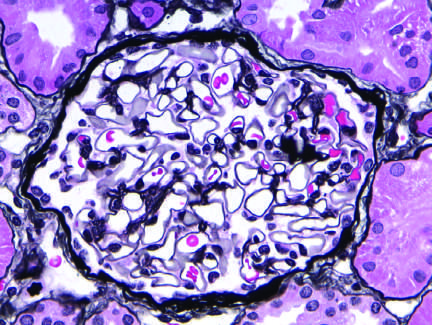how does the silver methenamine-stained glomerulus appear?
Answer the question using a single word or phrase. With a delicate basement membrane 